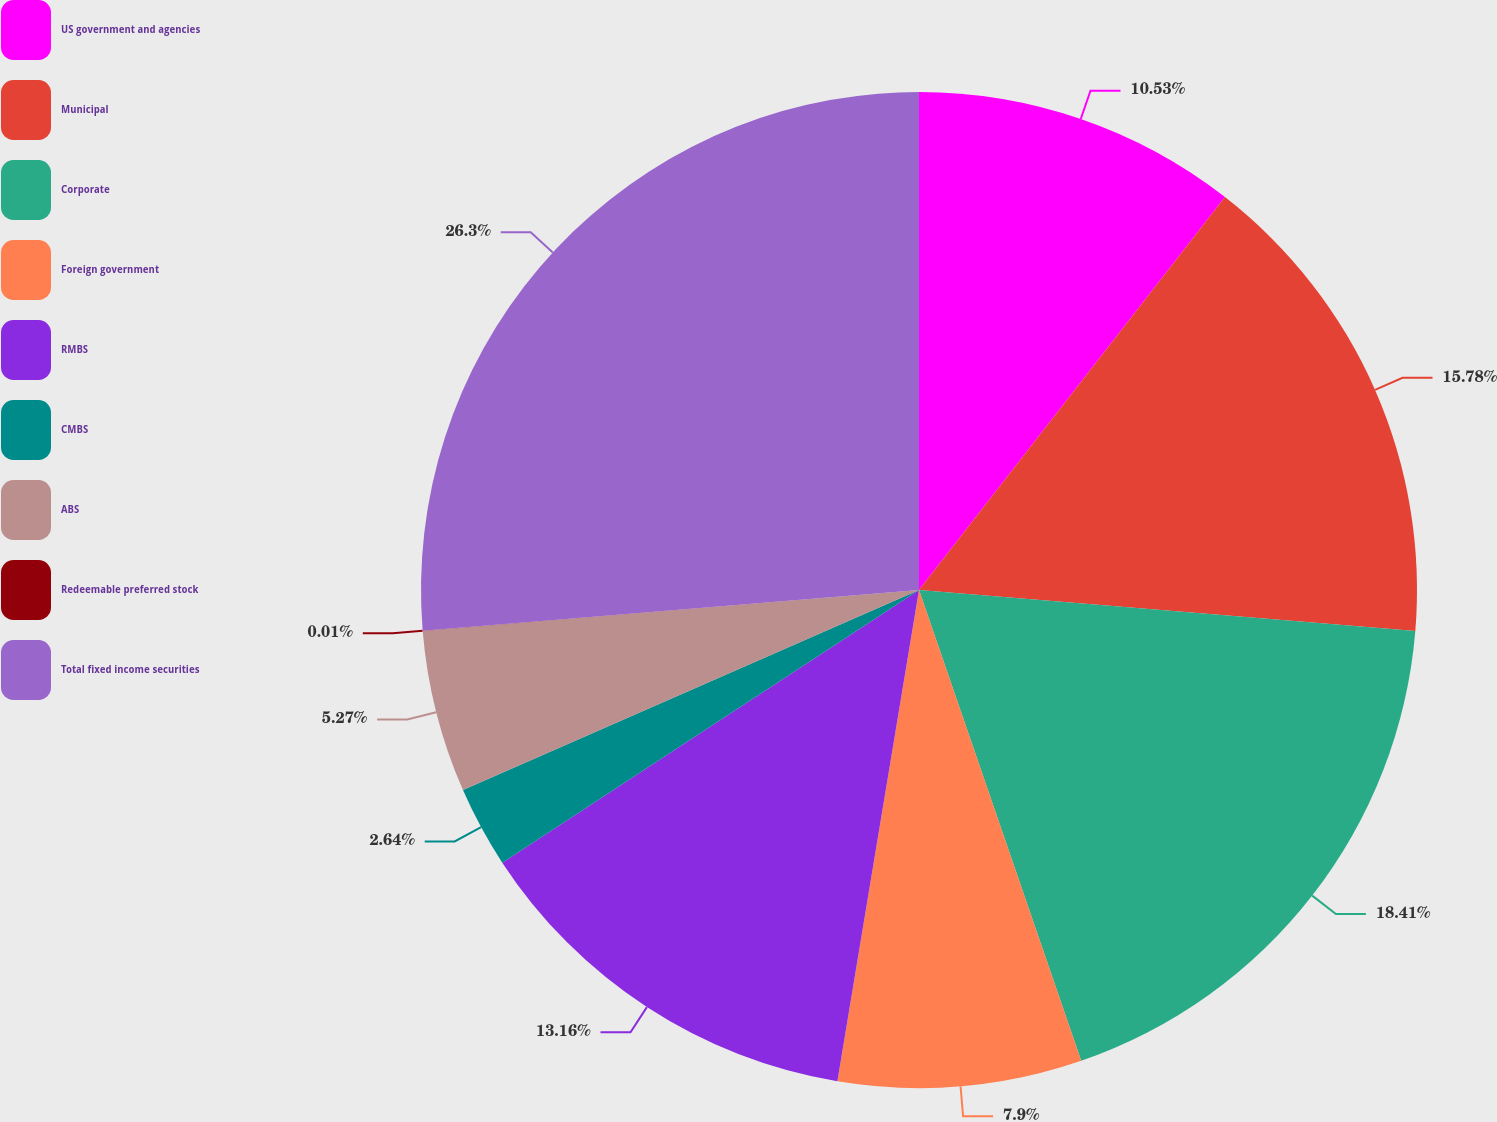Convert chart. <chart><loc_0><loc_0><loc_500><loc_500><pie_chart><fcel>US government and agencies<fcel>Municipal<fcel>Corporate<fcel>Foreign government<fcel>RMBS<fcel>CMBS<fcel>ABS<fcel>Redeemable preferred stock<fcel>Total fixed income securities<nl><fcel>10.53%<fcel>15.78%<fcel>18.41%<fcel>7.9%<fcel>13.16%<fcel>2.64%<fcel>5.27%<fcel>0.01%<fcel>26.3%<nl></chart> 